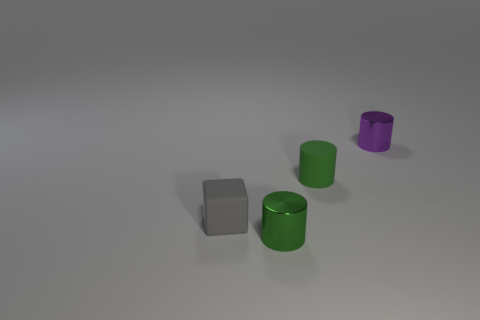Add 3 gray blocks. How many objects exist? 7 Subtract all cubes. How many objects are left? 3 Subtract all purple metal objects. Subtract all small gray matte things. How many objects are left? 2 Add 3 green cylinders. How many green cylinders are left? 5 Add 1 small blocks. How many small blocks exist? 2 Subtract 0 brown spheres. How many objects are left? 4 